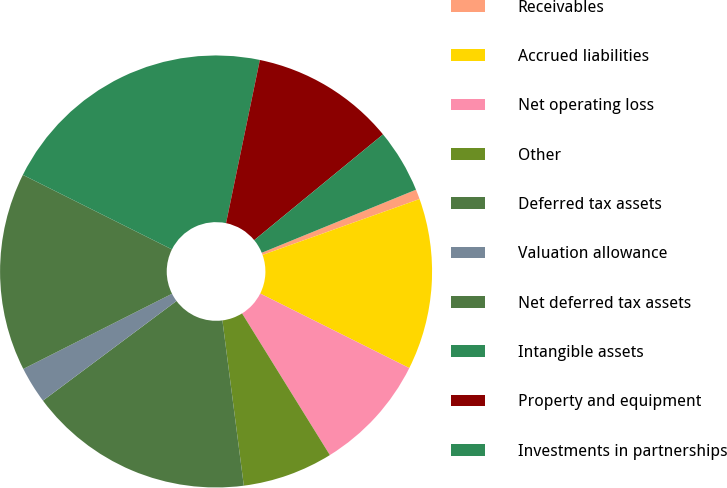Convert chart. <chart><loc_0><loc_0><loc_500><loc_500><pie_chart><fcel>Receivables<fcel>Accrued liabilities<fcel>Net operating loss<fcel>Other<fcel>Deferred tax assets<fcel>Valuation allowance<fcel>Net deferred tax assets<fcel>Intangible assets<fcel>Property and equipment<fcel>Investments in partnerships<nl><fcel>0.74%<fcel>12.82%<fcel>8.79%<fcel>6.78%<fcel>16.85%<fcel>2.75%<fcel>14.83%<fcel>20.87%<fcel>10.81%<fcel>4.76%<nl></chart> 